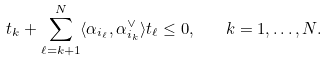<formula> <loc_0><loc_0><loc_500><loc_500>t _ { k } + \sum _ { \ell = k + 1 } ^ { N } \langle \alpha _ { i _ { \ell } } , \alpha _ { i _ { k } } ^ { \vee } \rangle t _ { \ell } \leq 0 , \quad k = 1 , \dots , N .</formula> 